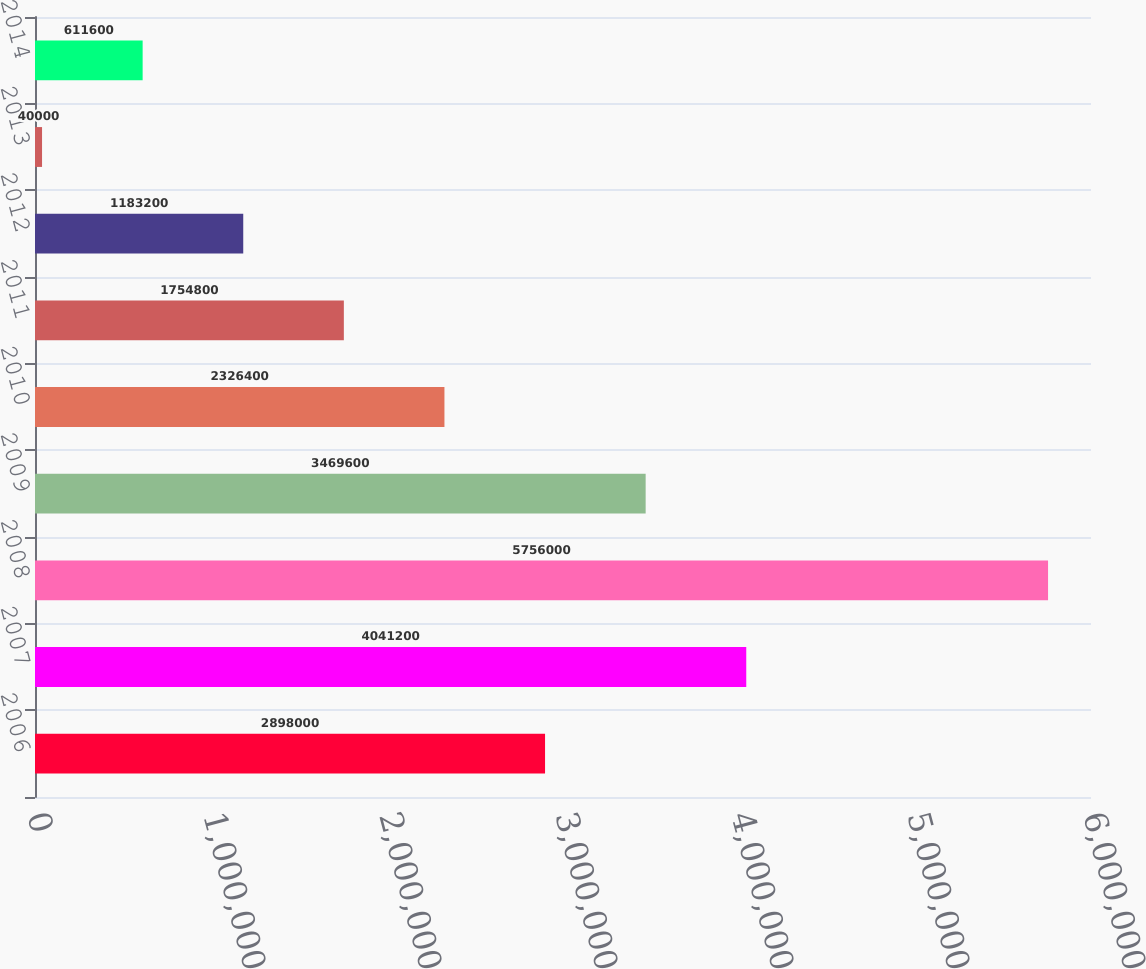Convert chart. <chart><loc_0><loc_0><loc_500><loc_500><bar_chart><fcel>2006<fcel>2007<fcel>2008<fcel>2009<fcel>2010<fcel>2011<fcel>2012<fcel>2013<fcel>2014<nl><fcel>2.898e+06<fcel>4.0412e+06<fcel>5.756e+06<fcel>3.4696e+06<fcel>2.3264e+06<fcel>1.7548e+06<fcel>1.1832e+06<fcel>40000<fcel>611600<nl></chart> 